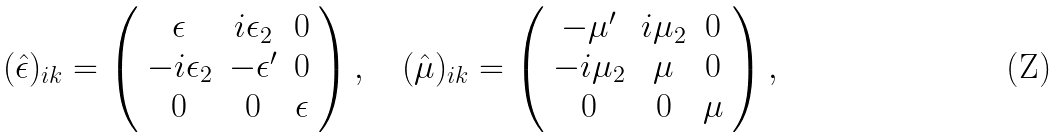Convert formula to latex. <formula><loc_0><loc_0><loc_500><loc_500>( \hat { \epsilon } ) _ { i k } = \left ( \begin{array} { c c c c } \epsilon & i \epsilon _ { 2 } & 0 \\ - i \epsilon _ { 2 } & - \epsilon ^ { \prime } & 0 \\ 0 & 0 & \epsilon \end{array} \right ) , \quad ( \hat { \mu } ) _ { i k } = \left ( \begin{array} { c c c c } - \mu ^ { \prime } & i \mu _ { 2 } & 0 \\ - i \mu _ { 2 } & \mu & 0 \\ 0 & 0 & \mu \end{array} \right ) ,</formula> 